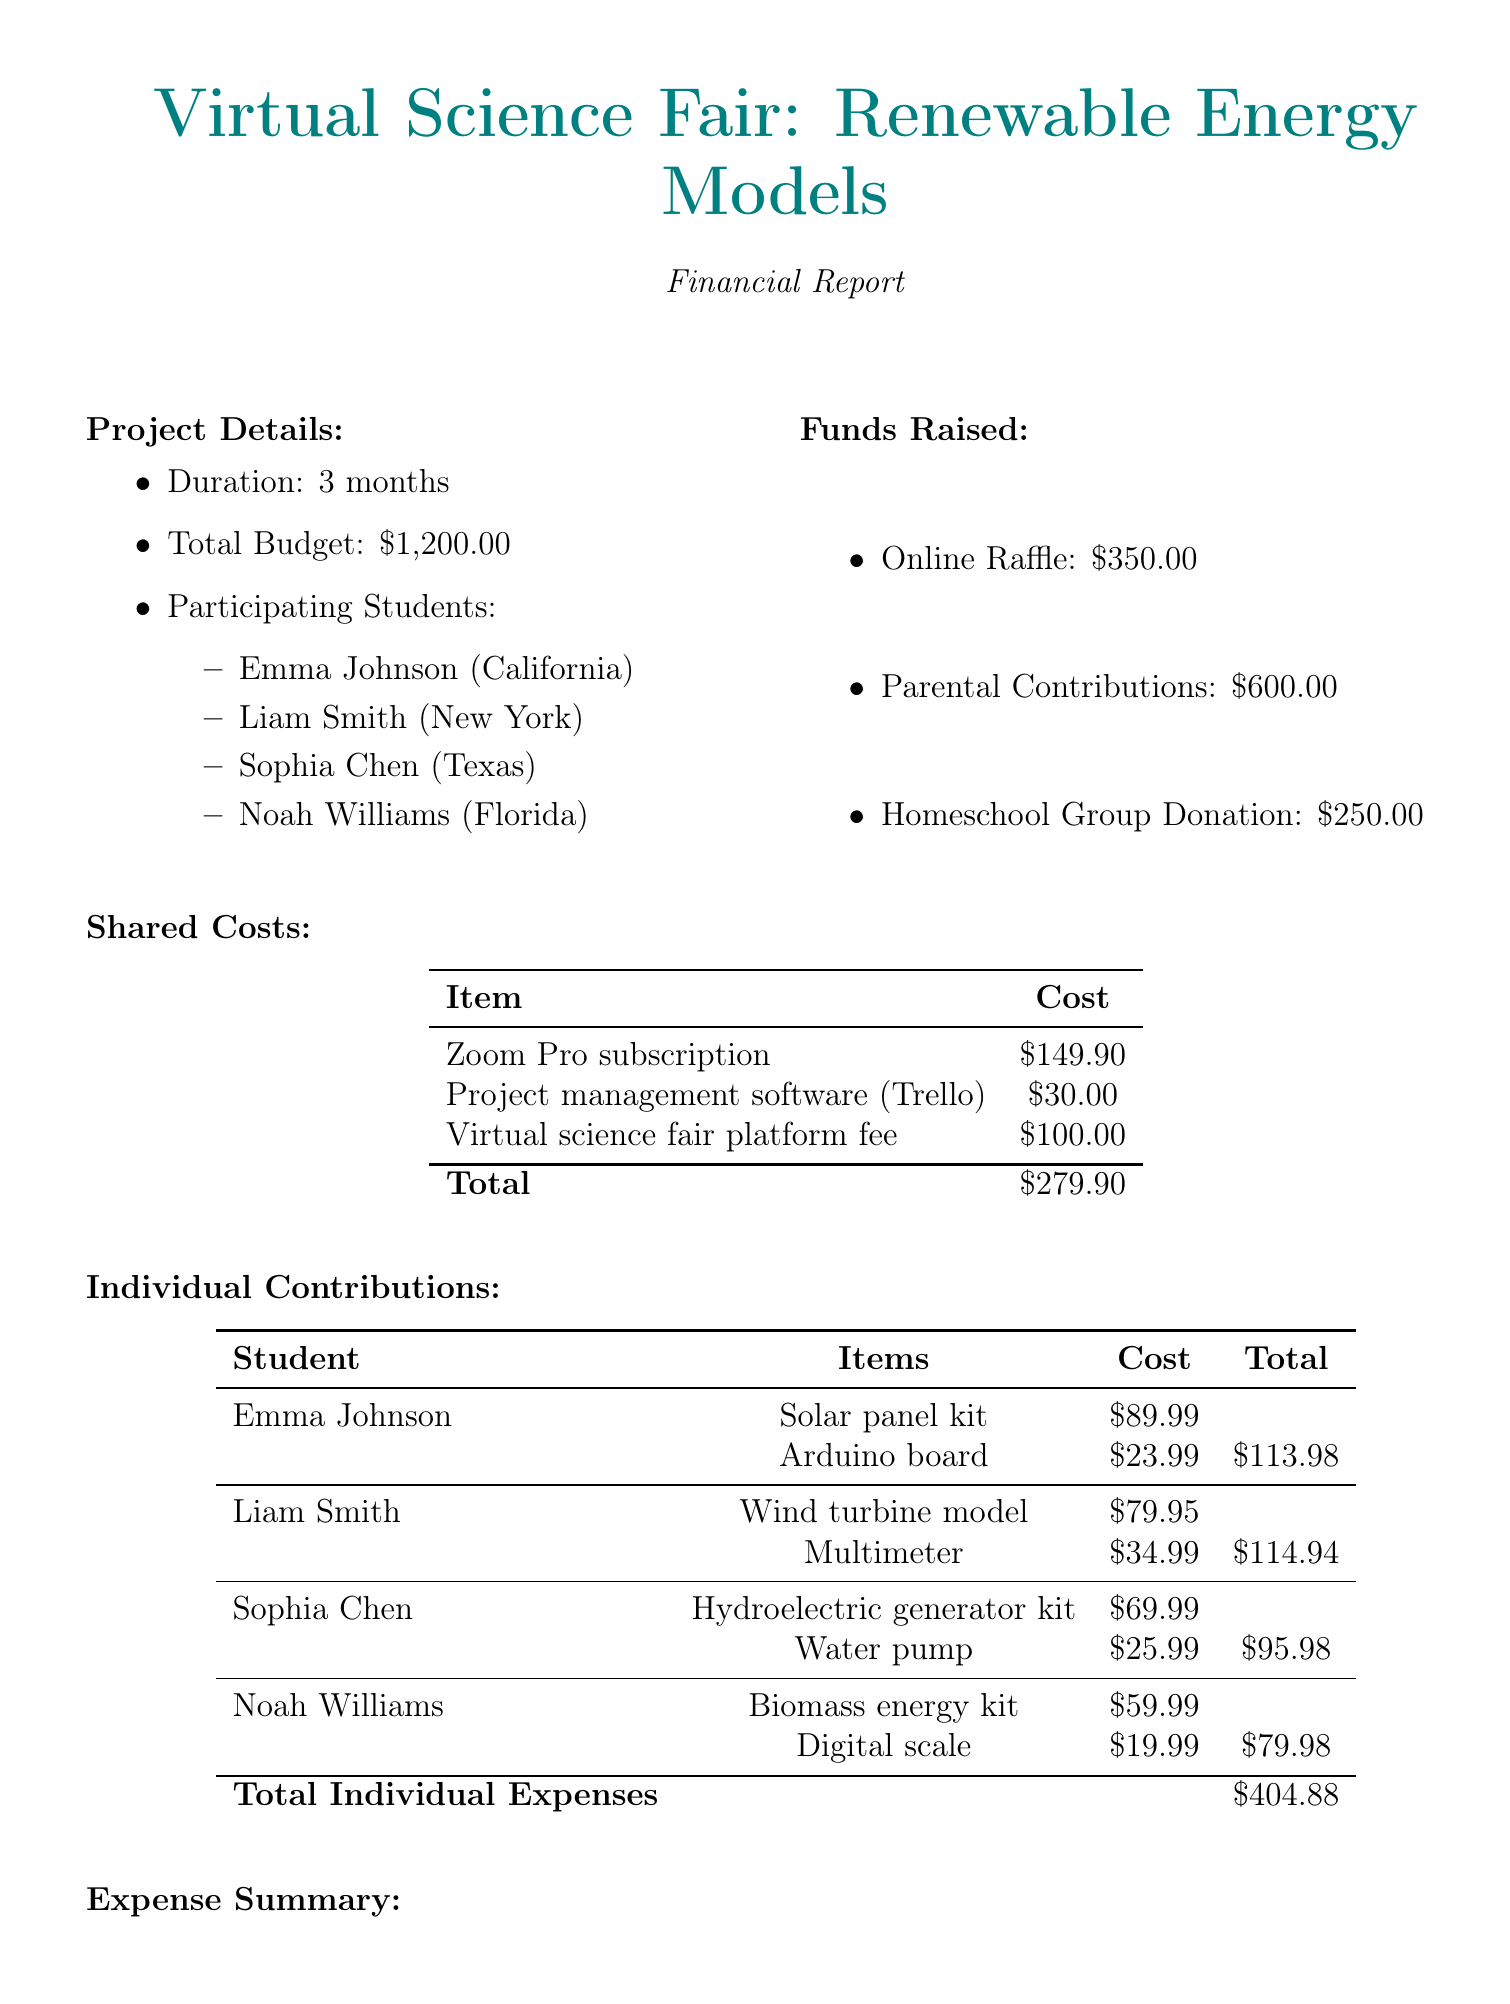What is the total budget for the project? The total budget is explicitly stated in the document as \$1,200.00.
Answer: \$1,200.00 How many participating students are in the project? The number of participating students can be counted from the list provided, which includes four names.
Answer: 4 What is the cost of the Zoom Pro subscription? The document lists the cost of the Zoom Pro subscription as one of the shared costs.
Answer: \$149.90 Which student's individual expenses total to the most? By reviewing the individual contributions, it appears that Liam Smith has the highest total expenses at \$114.94.
Answer: Liam Smith How much was raised from the online raffle? The amount raised from the online raffle is directly stated in the funds raised section.
Answer: \$350.00 What is the total amount spent on shared costs and individual expenses combined? The total spent is the sum of shared costs and individual expenses, which can be calculated as \$279.90 + \$404.88 = \$684.78.
Answer: \$684.78 What is the remaining funds after expenses? The remaining funds are presented in the expense summary section, showing what is left after expenses.
Answer: \$515.22 What type of project is this financial report for? The report specifies the project name related to renewable energy models in a virtual science fair context.
Answer: Virtual Science Fair: Renewable Energy Models 